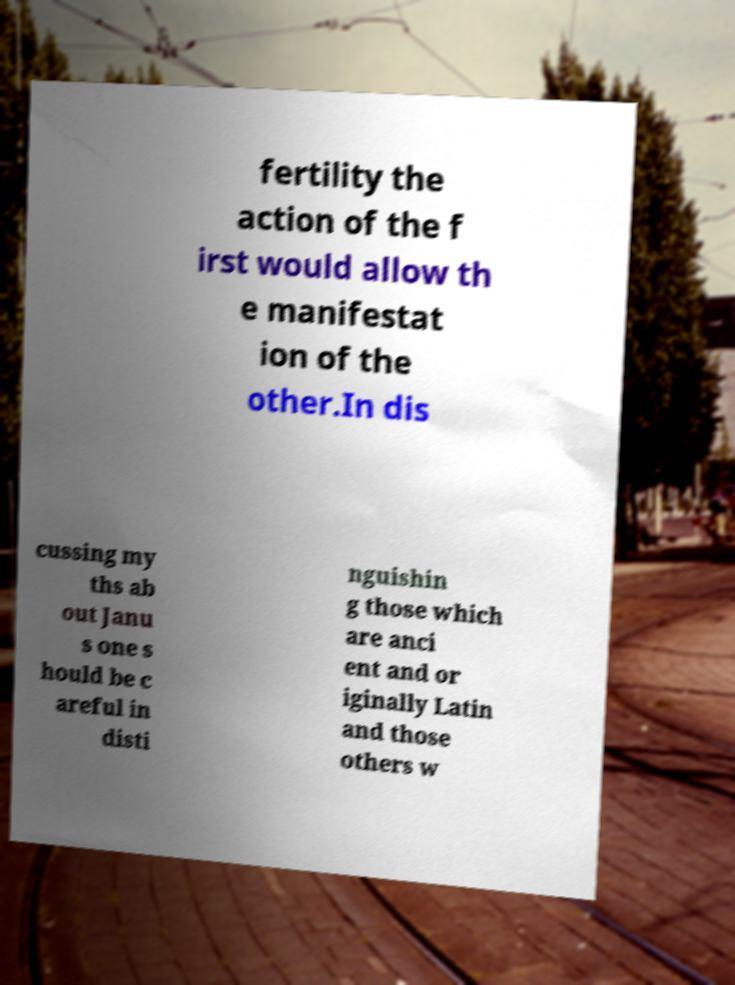Can you accurately transcribe the text from the provided image for me? fertility the action of the f irst would allow th e manifestat ion of the other.In dis cussing my ths ab out Janu s one s hould be c areful in disti nguishin g those which are anci ent and or iginally Latin and those others w 